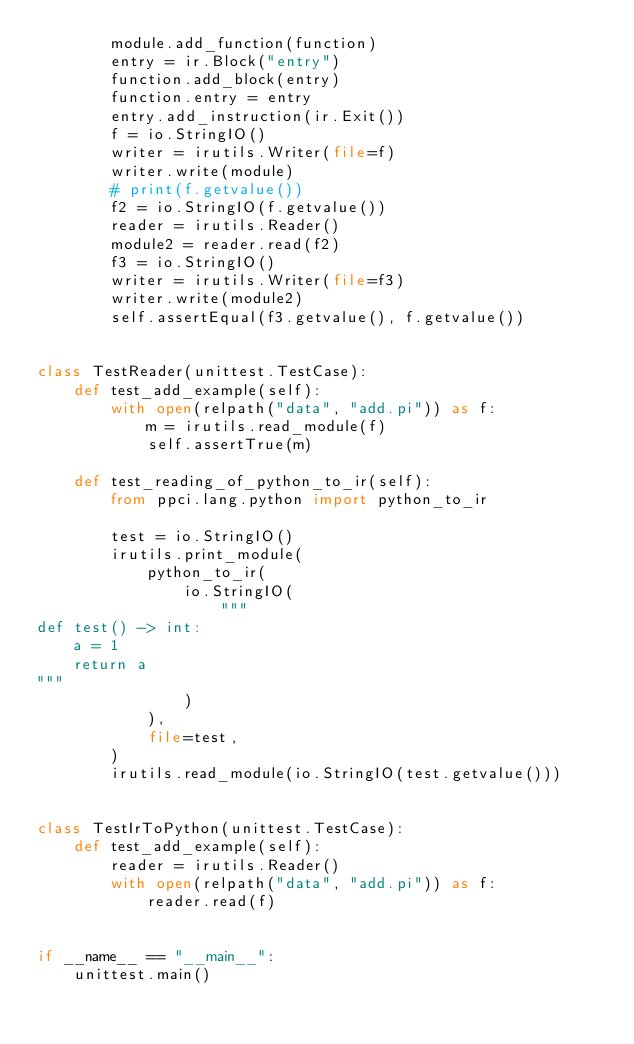<code> <loc_0><loc_0><loc_500><loc_500><_Python_>        module.add_function(function)
        entry = ir.Block("entry")
        function.add_block(entry)
        function.entry = entry
        entry.add_instruction(ir.Exit())
        f = io.StringIO()
        writer = irutils.Writer(file=f)
        writer.write(module)
        # print(f.getvalue())
        f2 = io.StringIO(f.getvalue())
        reader = irutils.Reader()
        module2 = reader.read(f2)
        f3 = io.StringIO()
        writer = irutils.Writer(file=f3)
        writer.write(module2)
        self.assertEqual(f3.getvalue(), f.getvalue())


class TestReader(unittest.TestCase):
    def test_add_example(self):
        with open(relpath("data", "add.pi")) as f:
            m = irutils.read_module(f)
            self.assertTrue(m)

    def test_reading_of_python_to_ir(self):
        from ppci.lang.python import python_to_ir

        test = io.StringIO()
        irutils.print_module(
            python_to_ir(
                io.StringIO(
                    """
def test() -> int:
    a = 1
    return a
"""
                )
            ),
            file=test,
        )
        irutils.read_module(io.StringIO(test.getvalue()))


class TestIrToPython(unittest.TestCase):
    def test_add_example(self):
        reader = irutils.Reader()
        with open(relpath("data", "add.pi")) as f:
            reader.read(f)


if __name__ == "__main__":
    unittest.main()
</code> 